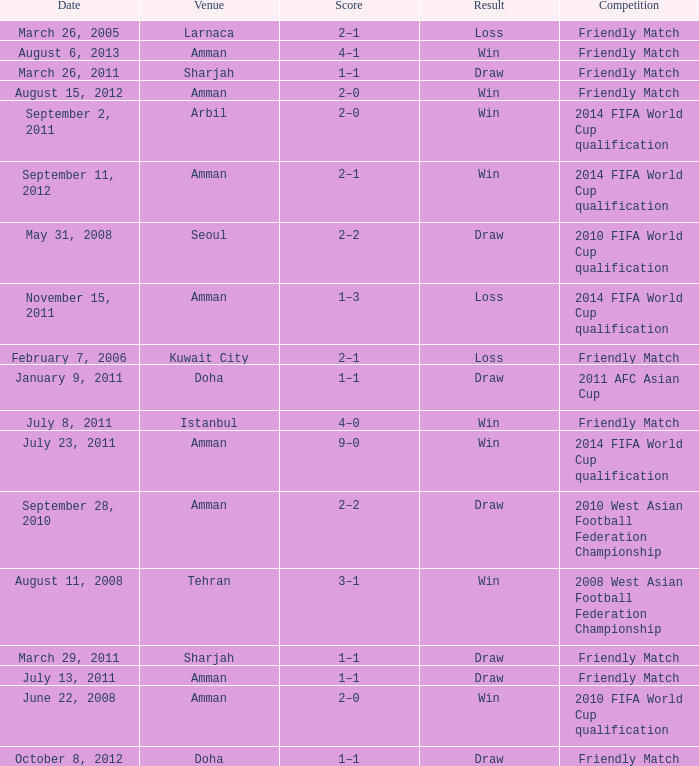What was the name of the competition that took place on may 31, 2008? 2010 FIFA World Cup qualification. 